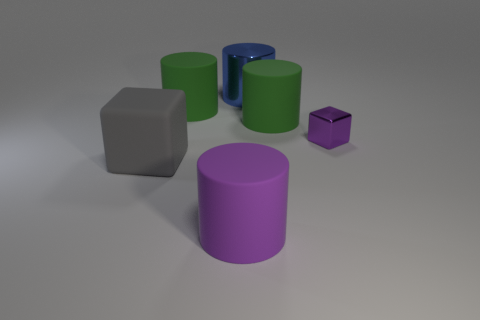What number of small purple rubber spheres are there?
Make the answer very short. 0. Are the green cylinder that is on the left side of the large shiny thing and the big gray block made of the same material?
Provide a succinct answer. Yes. There is a purple object behind the cube that is on the left side of the large metal object; what number of gray rubber things are to the right of it?
Offer a very short reply. 0. How big is the purple metallic cube?
Keep it short and to the point. Small. What size is the metal cube that is in front of the big blue metal cylinder?
Offer a very short reply. Small. Does the big thing that is in front of the large rubber cube have the same color as the tiny metal object in front of the large metallic thing?
Ensure brevity in your answer.  Yes. How many other things are there of the same shape as the big blue metallic thing?
Offer a very short reply. 3. Are there an equal number of large purple rubber things that are behind the tiny purple block and gray matte blocks right of the large block?
Ensure brevity in your answer.  Yes. Is the object in front of the big cube made of the same material as the purple thing that is behind the purple rubber cylinder?
Your answer should be compact. No. What number of other things are the same size as the blue cylinder?
Your answer should be very brief. 4. 